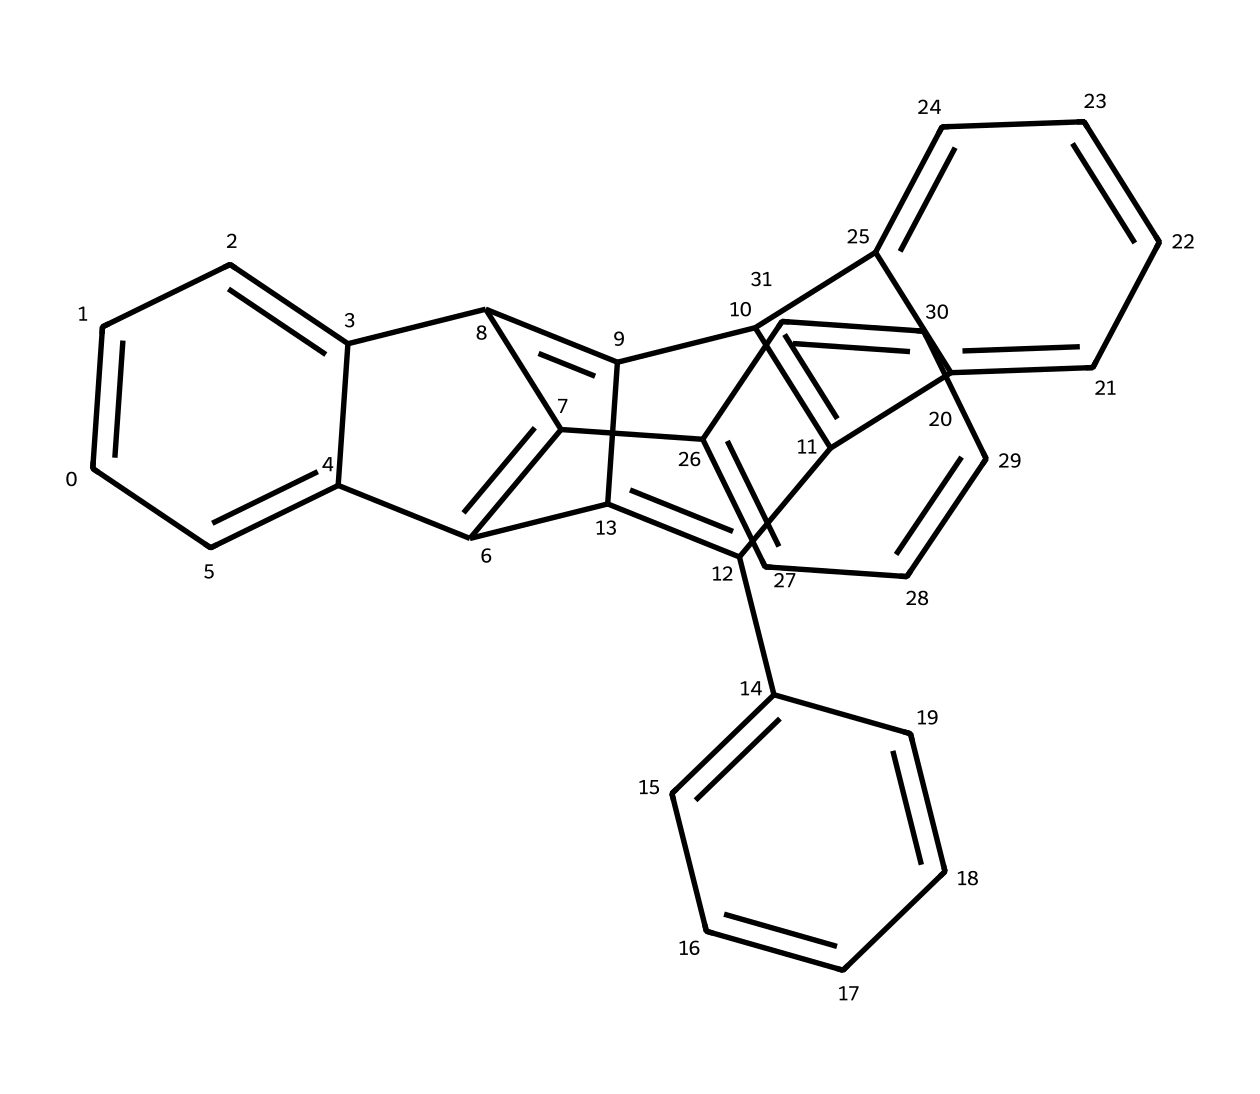What is the total number of carbon atoms in this quantum dot structure? The given SMILES represents a chemical structure containing multiple aromatic rings interconnected. Each letter "C" in the SMILES denotes a carbon atom. By counting them in the structure, we find there are 30 carbon atoms in total present in the chemical.
Answer: 30 How many double bonds are present in the chemical structure? In the SMILES representation, double bonds are typically indicated by the "=" symbol. By reviewing the structure, we can identify the locations and count them effectively. In this case, there are 18 double bonds throughout the molecule, which can be noted in various parts of the structure.
Answer: 18 What type of carbon structure is represented in this quantum dot? The structure comprises multiple interconnected aromatic rings, characteristic of a polycyclic aromatic hydrocarbon (PAH). This indicates that the molecule is predominantly made up of π-electron-rich carbon frameworks, commonly seen in quantum dots.
Answer: polycyclic aromatic hydrocarbon Which feature in the structure contributes to the vibrancy of the pigments? The pronounced presence of alternating single and double bonds across the aromatic rings allows for extended π-conjugation. This feature is crucial in determining the electronic properties, which contribute to the vibrancy of pigments encapsulated in the quantum dot structure.
Answer: π-conjugation What is the predominant type of bond in the structure? Analyzing the SMILES representation, the continuous interconnectedness of the carbon atoms through single and double bonds indicates that the predominant type of bond in this molecular structure is covalent, as these bonds link the carbon atoms firmly.
Answer: covalent How many rings are present in the chemical structure of this quantum dot? The structure shows several interconnected rings, which can be counted by visualizing the cyclic portions. By analyzing the structure from the SMILES, we find there are 8 distinct rings in total.
Answer: 8 What characteristic makes this compound suitable for long-lasting pigments? The stability and robustness of aromatic compounds due to their resonance structures provide enhanced protection against degradation from environmental factors. This characteristic makes the compound particularly suitable for developing long-lasting landscape pigments.
Answer: stability 